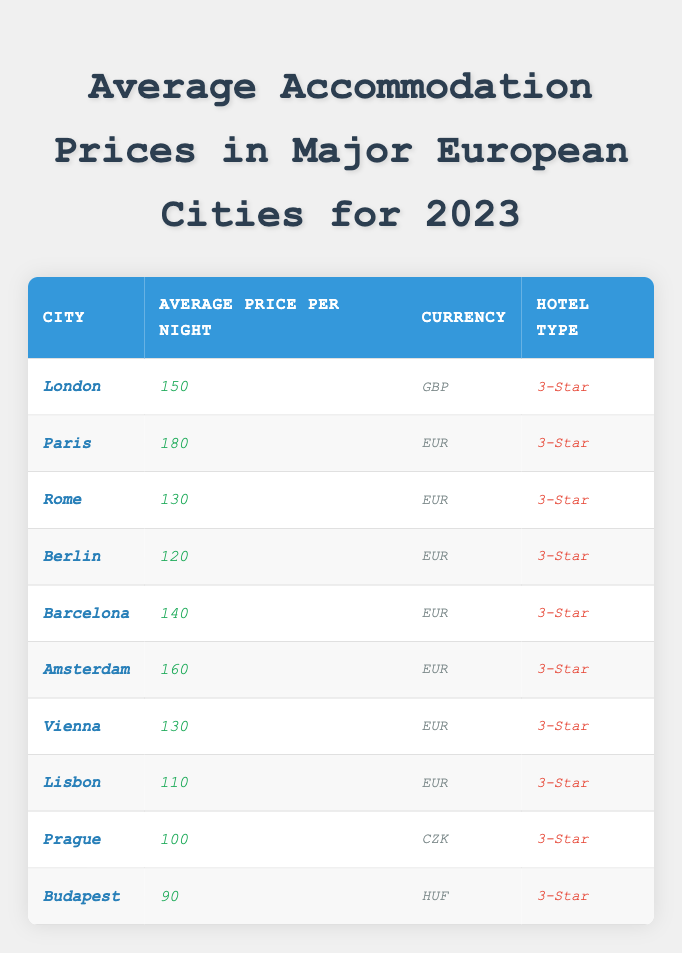What is the average price per night for accommodation in Paris? The table shows that the average price per night in Paris is listed as 180.
Answer: 180 Which city has the lowest accommodation price? Looking through the table, Budapest has the lowest average price at 90.
Answer: Budapest What is the currency used in Berlin? The table indicates that the currency used for accommodation prices in Berlin is EUR.
Answer: EUR How much more expensive is a night in London compared to Lisbon? The average price in London is 150, and in Lisbon, it is 110. The difference is 150 - 110 = 40.
Answer: 40 Is the price for accommodation in Amsterdam higher than in Vienna? The average price in Amsterdam is 160 and in Vienna is 130. Since 160 > 130 is true, the answer is yes.
Answer: Yes What is the total average accommodation price for all cities listed? To find the total, we add all average prices: 150 + 180 + 130 + 120 + 140 + 160 + 130 + 110 + 100 + 90 = 1,370.
Answer: 1,370 Calculate the average accommodation price across all cities. The total accommodation price is 1,370 and there are 10 cities, so the average is 1,370 / 10 = 137.
Answer: 137 What percentage of the cities have an average price above 130? The cities are: London (150), Paris (180), Rome (130), Berlin (120), Barcelona (140), Amsterdam (160), Vienna (130), Lisbon (110), Prague (100), and Budapest (90). Five cities have prices above 130 (London, Paris, Barcelona, Amsterdam) out of 10, which is (5/10)*100 = 50%.
Answer: 50% Which city has an accommodation price closest to 130 without going over? The cities that have prices close to but not exceeding 130 are Berlin (120) and Rome (130); since Rome is exactly 130, it is the answer.
Answer: Rome If a traveler stayed in Budapest and then moved to Berlin, how much more would they spend on accommodation per night? The average in Budapest is 90 and in Berlin is 120. The difference is 120 - 90 = 30.
Answer: 30 